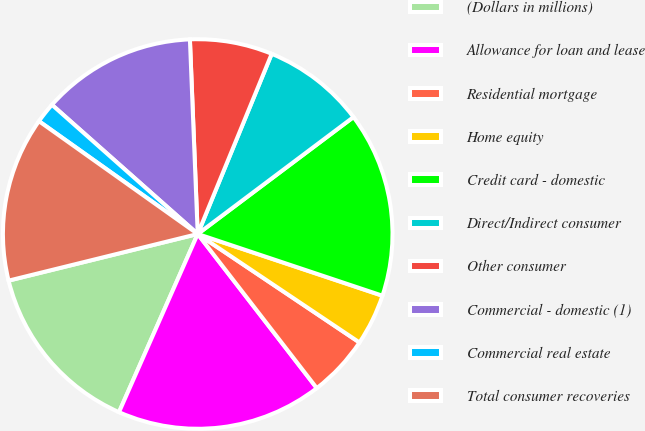Convert chart to OTSL. <chart><loc_0><loc_0><loc_500><loc_500><pie_chart><fcel>(Dollars in millions)<fcel>Allowance for loan and lease<fcel>Residential mortgage<fcel>Home equity<fcel>Credit card - domestic<fcel>Direct/Indirect consumer<fcel>Other consumer<fcel>Commercial - domestic (1)<fcel>Commercial real estate<fcel>Total consumer recoveries<nl><fcel>14.53%<fcel>17.09%<fcel>5.13%<fcel>4.27%<fcel>15.38%<fcel>8.55%<fcel>6.84%<fcel>12.82%<fcel>1.71%<fcel>13.68%<nl></chart> 